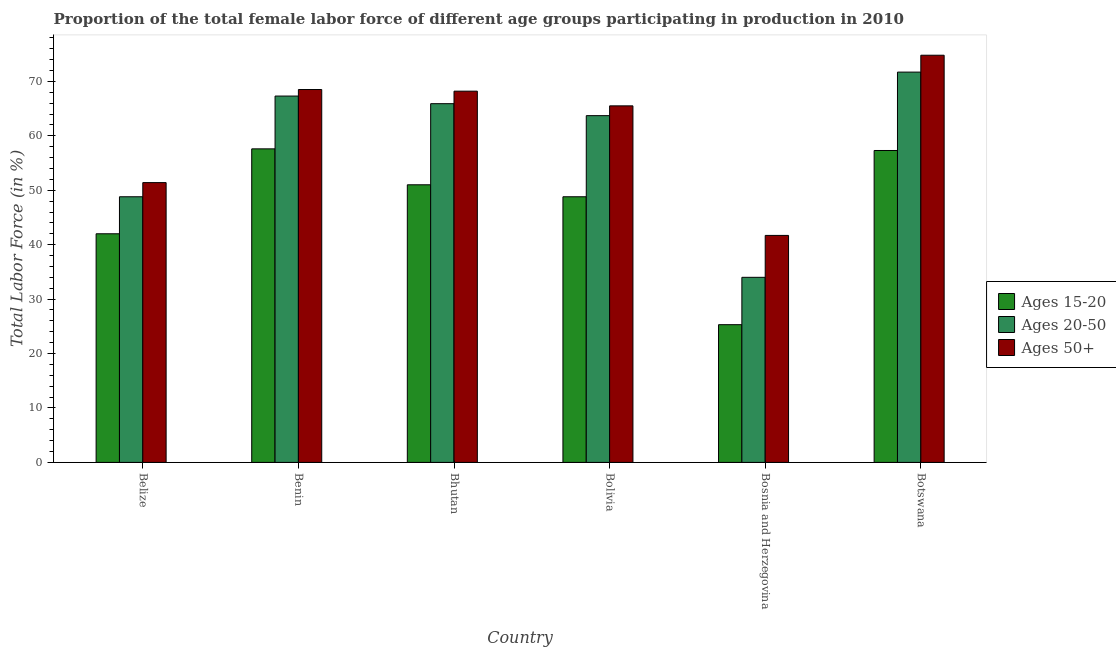How many groups of bars are there?
Offer a very short reply. 6. Are the number of bars on each tick of the X-axis equal?
Your response must be concise. Yes. How many bars are there on the 2nd tick from the left?
Ensure brevity in your answer.  3. What is the label of the 5th group of bars from the left?
Provide a short and direct response. Bosnia and Herzegovina. In how many cases, is the number of bars for a given country not equal to the number of legend labels?
Provide a short and direct response. 0. What is the percentage of female labor force above age 50 in Bhutan?
Your answer should be compact. 68.2. Across all countries, what is the maximum percentage of female labor force within the age group 20-50?
Make the answer very short. 71.7. Across all countries, what is the minimum percentage of female labor force within the age group 15-20?
Give a very brief answer. 25.3. In which country was the percentage of female labor force above age 50 maximum?
Offer a terse response. Botswana. In which country was the percentage of female labor force above age 50 minimum?
Offer a terse response. Bosnia and Herzegovina. What is the total percentage of female labor force above age 50 in the graph?
Make the answer very short. 370.1. What is the difference between the percentage of female labor force above age 50 in Belize and that in Bhutan?
Ensure brevity in your answer.  -16.8. What is the difference between the percentage of female labor force within the age group 20-50 in Belize and the percentage of female labor force within the age group 15-20 in Bosnia and Herzegovina?
Your answer should be very brief. 23.5. What is the average percentage of female labor force within the age group 20-50 per country?
Provide a short and direct response. 58.57. What is the difference between the percentage of female labor force above age 50 and percentage of female labor force within the age group 20-50 in Benin?
Offer a very short reply. 1.2. In how many countries, is the percentage of female labor force within the age group 15-20 greater than 74 %?
Your answer should be compact. 0. What is the ratio of the percentage of female labor force within the age group 15-20 in Bosnia and Herzegovina to that in Botswana?
Your response must be concise. 0.44. Is the percentage of female labor force within the age group 15-20 in Bolivia less than that in Bosnia and Herzegovina?
Provide a succinct answer. No. Is the difference between the percentage of female labor force within the age group 15-20 in Bhutan and Bosnia and Herzegovina greater than the difference between the percentage of female labor force above age 50 in Bhutan and Bosnia and Herzegovina?
Provide a succinct answer. No. What is the difference between the highest and the second highest percentage of female labor force above age 50?
Provide a short and direct response. 6.3. What is the difference between the highest and the lowest percentage of female labor force above age 50?
Offer a terse response. 33.1. In how many countries, is the percentage of female labor force within the age group 15-20 greater than the average percentage of female labor force within the age group 15-20 taken over all countries?
Make the answer very short. 4. What does the 3rd bar from the left in Botswana represents?
Offer a very short reply. Ages 50+. What does the 1st bar from the right in Belize represents?
Give a very brief answer. Ages 50+. Is it the case that in every country, the sum of the percentage of female labor force within the age group 15-20 and percentage of female labor force within the age group 20-50 is greater than the percentage of female labor force above age 50?
Make the answer very short. Yes. How many bars are there?
Your response must be concise. 18. What is the difference between two consecutive major ticks on the Y-axis?
Give a very brief answer. 10. Are the values on the major ticks of Y-axis written in scientific E-notation?
Ensure brevity in your answer.  No. Does the graph contain any zero values?
Provide a succinct answer. No. Does the graph contain grids?
Your answer should be very brief. No. Where does the legend appear in the graph?
Your answer should be compact. Center right. What is the title of the graph?
Your response must be concise. Proportion of the total female labor force of different age groups participating in production in 2010. What is the label or title of the X-axis?
Offer a terse response. Country. What is the label or title of the Y-axis?
Give a very brief answer. Total Labor Force (in %). What is the Total Labor Force (in %) of Ages 15-20 in Belize?
Ensure brevity in your answer.  42. What is the Total Labor Force (in %) of Ages 20-50 in Belize?
Your answer should be compact. 48.8. What is the Total Labor Force (in %) of Ages 50+ in Belize?
Your response must be concise. 51.4. What is the Total Labor Force (in %) in Ages 15-20 in Benin?
Your answer should be very brief. 57.6. What is the Total Labor Force (in %) of Ages 20-50 in Benin?
Keep it short and to the point. 67.3. What is the Total Labor Force (in %) in Ages 50+ in Benin?
Give a very brief answer. 68.5. What is the Total Labor Force (in %) of Ages 15-20 in Bhutan?
Your answer should be compact. 51. What is the Total Labor Force (in %) in Ages 20-50 in Bhutan?
Make the answer very short. 65.9. What is the Total Labor Force (in %) of Ages 50+ in Bhutan?
Your answer should be very brief. 68.2. What is the Total Labor Force (in %) of Ages 15-20 in Bolivia?
Ensure brevity in your answer.  48.8. What is the Total Labor Force (in %) in Ages 20-50 in Bolivia?
Your response must be concise. 63.7. What is the Total Labor Force (in %) of Ages 50+ in Bolivia?
Your answer should be compact. 65.5. What is the Total Labor Force (in %) in Ages 15-20 in Bosnia and Herzegovina?
Your response must be concise. 25.3. What is the Total Labor Force (in %) in Ages 20-50 in Bosnia and Herzegovina?
Keep it short and to the point. 34. What is the Total Labor Force (in %) of Ages 50+ in Bosnia and Herzegovina?
Provide a short and direct response. 41.7. What is the Total Labor Force (in %) of Ages 15-20 in Botswana?
Give a very brief answer. 57.3. What is the Total Labor Force (in %) in Ages 20-50 in Botswana?
Offer a terse response. 71.7. What is the Total Labor Force (in %) of Ages 50+ in Botswana?
Your response must be concise. 74.8. Across all countries, what is the maximum Total Labor Force (in %) of Ages 15-20?
Ensure brevity in your answer.  57.6. Across all countries, what is the maximum Total Labor Force (in %) of Ages 20-50?
Ensure brevity in your answer.  71.7. Across all countries, what is the maximum Total Labor Force (in %) in Ages 50+?
Provide a short and direct response. 74.8. Across all countries, what is the minimum Total Labor Force (in %) in Ages 15-20?
Keep it short and to the point. 25.3. Across all countries, what is the minimum Total Labor Force (in %) of Ages 20-50?
Your answer should be very brief. 34. Across all countries, what is the minimum Total Labor Force (in %) in Ages 50+?
Give a very brief answer. 41.7. What is the total Total Labor Force (in %) in Ages 15-20 in the graph?
Make the answer very short. 282. What is the total Total Labor Force (in %) of Ages 20-50 in the graph?
Provide a succinct answer. 351.4. What is the total Total Labor Force (in %) of Ages 50+ in the graph?
Your answer should be very brief. 370.1. What is the difference between the Total Labor Force (in %) of Ages 15-20 in Belize and that in Benin?
Your response must be concise. -15.6. What is the difference between the Total Labor Force (in %) of Ages 20-50 in Belize and that in Benin?
Your response must be concise. -18.5. What is the difference between the Total Labor Force (in %) of Ages 50+ in Belize and that in Benin?
Offer a very short reply. -17.1. What is the difference between the Total Labor Force (in %) of Ages 15-20 in Belize and that in Bhutan?
Offer a terse response. -9. What is the difference between the Total Labor Force (in %) of Ages 20-50 in Belize and that in Bhutan?
Your answer should be compact. -17.1. What is the difference between the Total Labor Force (in %) in Ages 50+ in Belize and that in Bhutan?
Offer a terse response. -16.8. What is the difference between the Total Labor Force (in %) of Ages 15-20 in Belize and that in Bolivia?
Provide a succinct answer. -6.8. What is the difference between the Total Labor Force (in %) of Ages 20-50 in Belize and that in Bolivia?
Your response must be concise. -14.9. What is the difference between the Total Labor Force (in %) in Ages 50+ in Belize and that in Bolivia?
Your answer should be very brief. -14.1. What is the difference between the Total Labor Force (in %) of Ages 15-20 in Belize and that in Bosnia and Herzegovina?
Keep it short and to the point. 16.7. What is the difference between the Total Labor Force (in %) in Ages 50+ in Belize and that in Bosnia and Herzegovina?
Offer a terse response. 9.7. What is the difference between the Total Labor Force (in %) in Ages 15-20 in Belize and that in Botswana?
Provide a succinct answer. -15.3. What is the difference between the Total Labor Force (in %) of Ages 20-50 in Belize and that in Botswana?
Provide a short and direct response. -22.9. What is the difference between the Total Labor Force (in %) of Ages 50+ in Belize and that in Botswana?
Your response must be concise. -23.4. What is the difference between the Total Labor Force (in %) of Ages 20-50 in Benin and that in Bhutan?
Provide a succinct answer. 1.4. What is the difference between the Total Labor Force (in %) of Ages 50+ in Benin and that in Bhutan?
Offer a terse response. 0.3. What is the difference between the Total Labor Force (in %) of Ages 20-50 in Benin and that in Bolivia?
Offer a very short reply. 3.6. What is the difference between the Total Labor Force (in %) of Ages 15-20 in Benin and that in Bosnia and Herzegovina?
Provide a succinct answer. 32.3. What is the difference between the Total Labor Force (in %) of Ages 20-50 in Benin and that in Bosnia and Herzegovina?
Make the answer very short. 33.3. What is the difference between the Total Labor Force (in %) of Ages 50+ in Benin and that in Bosnia and Herzegovina?
Ensure brevity in your answer.  26.8. What is the difference between the Total Labor Force (in %) in Ages 15-20 in Benin and that in Botswana?
Offer a terse response. 0.3. What is the difference between the Total Labor Force (in %) of Ages 50+ in Benin and that in Botswana?
Offer a terse response. -6.3. What is the difference between the Total Labor Force (in %) of Ages 20-50 in Bhutan and that in Bolivia?
Offer a very short reply. 2.2. What is the difference between the Total Labor Force (in %) in Ages 50+ in Bhutan and that in Bolivia?
Your answer should be compact. 2.7. What is the difference between the Total Labor Force (in %) in Ages 15-20 in Bhutan and that in Bosnia and Herzegovina?
Offer a terse response. 25.7. What is the difference between the Total Labor Force (in %) in Ages 20-50 in Bhutan and that in Bosnia and Herzegovina?
Offer a terse response. 31.9. What is the difference between the Total Labor Force (in %) in Ages 50+ in Bhutan and that in Bosnia and Herzegovina?
Your answer should be very brief. 26.5. What is the difference between the Total Labor Force (in %) of Ages 50+ in Bhutan and that in Botswana?
Offer a terse response. -6.6. What is the difference between the Total Labor Force (in %) in Ages 15-20 in Bolivia and that in Bosnia and Herzegovina?
Offer a very short reply. 23.5. What is the difference between the Total Labor Force (in %) in Ages 20-50 in Bolivia and that in Bosnia and Herzegovina?
Keep it short and to the point. 29.7. What is the difference between the Total Labor Force (in %) in Ages 50+ in Bolivia and that in Bosnia and Herzegovina?
Offer a very short reply. 23.8. What is the difference between the Total Labor Force (in %) of Ages 15-20 in Bolivia and that in Botswana?
Offer a very short reply. -8.5. What is the difference between the Total Labor Force (in %) of Ages 15-20 in Bosnia and Herzegovina and that in Botswana?
Your response must be concise. -32. What is the difference between the Total Labor Force (in %) of Ages 20-50 in Bosnia and Herzegovina and that in Botswana?
Your answer should be very brief. -37.7. What is the difference between the Total Labor Force (in %) in Ages 50+ in Bosnia and Herzegovina and that in Botswana?
Provide a succinct answer. -33.1. What is the difference between the Total Labor Force (in %) in Ages 15-20 in Belize and the Total Labor Force (in %) in Ages 20-50 in Benin?
Provide a succinct answer. -25.3. What is the difference between the Total Labor Force (in %) of Ages 15-20 in Belize and the Total Labor Force (in %) of Ages 50+ in Benin?
Make the answer very short. -26.5. What is the difference between the Total Labor Force (in %) of Ages 20-50 in Belize and the Total Labor Force (in %) of Ages 50+ in Benin?
Offer a terse response. -19.7. What is the difference between the Total Labor Force (in %) of Ages 15-20 in Belize and the Total Labor Force (in %) of Ages 20-50 in Bhutan?
Offer a terse response. -23.9. What is the difference between the Total Labor Force (in %) in Ages 15-20 in Belize and the Total Labor Force (in %) in Ages 50+ in Bhutan?
Keep it short and to the point. -26.2. What is the difference between the Total Labor Force (in %) in Ages 20-50 in Belize and the Total Labor Force (in %) in Ages 50+ in Bhutan?
Offer a terse response. -19.4. What is the difference between the Total Labor Force (in %) in Ages 15-20 in Belize and the Total Labor Force (in %) in Ages 20-50 in Bolivia?
Provide a succinct answer. -21.7. What is the difference between the Total Labor Force (in %) of Ages 15-20 in Belize and the Total Labor Force (in %) of Ages 50+ in Bolivia?
Make the answer very short. -23.5. What is the difference between the Total Labor Force (in %) of Ages 20-50 in Belize and the Total Labor Force (in %) of Ages 50+ in Bolivia?
Your response must be concise. -16.7. What is the difference between the Total Labor Force (in %) in Ages 15-20 in Belize and the Total Labor Force (in %) in Ages 20-50 in Bosnia and Herzegovina?
Make the answer very short. 8. What is the difference between the Total Labor Force (in %) of Ages 15-20 in Belize and the Total Labor Force (in %) of Ages 20-50 in Botswana?
Your answer should be very brief. -29.7. What is the difference between the Total Labor Force (in %) in Ages 15-20 in Belize and the Total Labor Force (in %) in Ages 50+ in Botswana?
Your answer should be compact. -32.8. What is the difference between the Total Labor Force (in %) in Ages 20-50 in Belize and the Total Labor Force (in %) in Ages 50+ in Botswana?
Provide a short and direct response. -26. What is the difference between the Total Labor Force (in %) of Ages 20-50 in Benin and the Total Labor Force (in %) of Ages 50+ in Bhutan?
Your answer should be very brief. -0.9. What is the difference between the Total Labor Force (in %) of Ages 15-20 in Benin and the Total Labor Force (in %) of Ages 20-50 in Bosnia and Herzegovina?
Keep it short and to the point. 23.6. What is the difference between the Total Labor Force (in %) in Ages 15-20 in Benin and the Total Labor Force (in %) in Ages 50+ in Bosnia and Herzegovina?
Ensure brevity in your answer.  15.9. What is the difference between the Total Labor Force (in %) of Ages 20-50 in Benin and the Total Labor Force (in %) of Ages 50+ in Bosnia and Herzegovina?
Your answer should be very brief. 25.6. What is the difference between the Total Labor Force (in %) in Ages 15-20 in Benin and the Total Labor Force (in %) in Ages 20-50 in Botswana?
Provide a succinct answer. -14.1. What is the difference between the Total Labor Force (in %) in Ages 15-20 in Benin and the Total Labor Force (in %) in Ages 50+ in Botswana?
Your response must be concise. -17.2. What is the difference between the Total Labor Force (in %) in Ages 15-20 in Bhutan and the Total Labor Force (in %) in Ages 20-50 in Bolivia?
Offer a terse response. -12.7. What is the difference between the Total Labor Force (in %) of Ages 15-20 in Bhutan and the Total Labor Force (in %) of Ages 20-50 in Bosnia and Herzegovina?
Your answer should be compact. 17. What is the difference between the Total Labor Force (in %) in Ages 20-50 in Bhutan and the Total Labor Force (in %) in Ages 50+ in Bosnia and Herzegovina?
Ensure brevity in your answer.  24.2. What is the difference between the Total Labor Force (in %) in Ages 15-20 in Bhutan and the Total Labor Force (in %) in Ages 20-50 in Botswana?
Your response must be concise. -20.7. What is the difference between the Total Labor Force (in %) in Ages 15-20 in Bhutan and the Total Labor Force (in %) in Ages 50+ in Botswana?
Ensure brevity in your answer.  -23.8. What is the difference between the Total Labor Force (in %) in Ages 15-20 in Bolivia and the Total Labor Force (in %) in Ages 20-50 in Bosnia and Herzegovina?
Your answer should be very brief. 14.8. What is the difference between the Total Labor Force (in %) in Ages 15-20 in Bolivia and the Total Labor Force (in %) in Ages 20-50 in Botswana?
Make the answer very short. -22.9. What is the difference between the Total Labor Force (in %) of Ages 20-50 in Bolivia and the Total Labor Force (in %) of Ages 50+ in Botswana?
Offer a very short reply. -11.1. What is the difference between the Total Labor Force (in %) in Ages 15-20 in Bosnia and Herzegovina and the Total Labor Force (in %) in Ages 20-50 in Botswana?
Your answer should be compact. -46.4. What is the difference between the Total Labor Force (in %) of Ages 15-20 in Bosnia and Herzegovina and the Total Labor Force (in %) of Ages 50+ in Botswana?
Offer a terse response. -49.5. What is the difference between the Total Labor Force (in %) of Ages 20-50 in Bosnia and Herzegovina and the Total Labor Force (in %) of Ages 50+ in Botswana?
Your answer should be compact. -40.8. What is the average Total Labor Force (in %) in Ages 15-20 per country?
Offer a terse response. 47. What is the average Total Labor Force (in %) in Ages 20-50 per country?
Make the answer very short. 58.57. What is the average Total Labor Force (in %) in Ages 50+ per country?
Your answer should be compact. 61.68. What is the difference between the Total Labor Force (in %) in Ages 20-50 and Total Labor Force (in %) in Ages 50+ in Benin?
Provide a short and direct response. -1.2. What is the difference between the Total Labor Force (in %) of Ages 15-20 and Total Labor Force (in %) of Ages 20-50 in Bhutan?
Your answer should be very brief. -14.9. What is the difference between the Total Labor Force (in %) in Ages 15-20 and Total Labor Force (in %) in Ages 50+ in Bhutan?
Offer a terse response. -17.2. What is the difference between the Total Labor Force (in %) in Ages 15-20 and Total Labor Force (in %) in Ages 20-50 in Bolivia?
Provide a short and direct response. -14.9. What is the difference between the Total Labor Force (in %) in Ages 15-20 and Total Labor Force (in %) in Ages 50+ in Bolivia?
Your answer should be very brief. -16.7. What is the difference between the Total Labor Force (in %) of Ages 20-50 and Total Labor Force (in %) of Ages 50+ in Bolivia?
Give a very brief answer. -1.8. What is the difference between the Total Labor Force (in %) of Ages 15-20 and Total Labor Force (in %) of Ages 50+ in Bosnia and Herzegovina?
Your answer should be compact. -16.4. What is the difference between the Total Labor Force (in %) in Ages 20-50 and Total Labor Force (in %) in Ages 50+ in Bosnia and Herzegovina?
Offer a very short reply. -7.7. What is the difference between the Total Labor Force (in %) of Ages 15-20 and Total Labor Force (in %) of Ages 20-50 in Botswana?
Your answer should be compact. -14.4. What is the difference between the Total Labor Force (in %) of Ages 15-20 and Total Labor Force (in %) of Ages 50+ in Botswana?
Offer a very short reply. -17.5. What is the difference between the Total Labor Force (in %) in Ages 20-50 and Total Labor Force (in %) in Ages 50+ in Botswana?
Your answer should be very brief. -3.1. What is the ratio of the Total Labor Force (in %) in Ages 15-20 in Belize to that in Benin?
Ensure brevity in your answer.  0.73. What is the ratio of the Total Labor Force (in %) in Ages 20-50 in Belize to that in Benin?
Your answer should be compact. 0.73. What is the ratio of the Total Labor Force (in %) in Ages 50+ in Belize to that in Benin?
Give a very brief answer. 0.75. What is the ratio of the Total Labor Force (in %) in Ages 15-20 in Belize to that in Bhutan?
Keep it short and to the point. 0.82. What is the ratio of the Total Labor Force (in %) in Ages 20-50 in Belize to that in Bhutan?
Offer a terse response. 0.74. What is the ratio of the Total Labor Force (in %) in Ages 50+ in Belize to that in Bhutan?
Make the answer very short. 0.75. What is the ratio of the Total Labor Force (in %) in Ages 15-20 in Belize to that in Bolivia?
Provide a succinct answer. 0.86. What is the ratio of the Total Labor Force (in %) of Ages 20-50 in Belize to that in Bolivia?
Your answer should be very brief. 0.77. What is the ratio of the Total Labor Force (in %) of Ages 50+ in Belize to that in Bolivia?
Your answer should be compact. 0.78. What is the ratio of the Total Labor Force (in %) in Ages 15-20 in Belize to that in Bosnia and Herzegovina?
Your response must be concise. 1.66. What is the ratio of the Total Labor Force (in %) in Ages 20-50 in Belize to that in Bosnia and Herzegovina?
Offer a very short reply. 1.44. What is the ratio of the Total Labor Force (in %) of Ages 50+ in Belize to that in Bosnia and Herzegovina?
Offer a terse response. 1.23. What is the ratio of the Total Labor Force (in %) in Ages 15-20 in Belize to that in Botswana?
Provide a short and direct response. 0.73. What is the ratio of the Total Labor Force (in %) of Ages 20-50 in Belize to that in Botswana?
Your answer should be compact. 0.68. What is the ratio of the Total Labor Force (in %) of Ages 50+ in Belize to that in Botswana?
Offer a very short reply. 0.69. What is the ratio of the Total Labor Force (in %) of Ages 15-20 in Benin to that in Bhutan?
Provide a succinct answer. 1.13. What is the ratio of the Total Labor Force (in %) of Ages 20-50 in Benin to that in Bhutan?
Provide a short and direct response. 1.02. What is the ratio of the Total Labor Force (in %) of Ages 50+ in Benin to that in Bhutan?
Ensure brevity in your answer.  1. What is the ratio of the Total Labor Force (in %) of Ages 15-20 in Benin to that in Bolivia?
Provide a short and direct response. 1.18. What is the ratio of the Total Labor Force (in %) of Ages 20-50 in Benin to that in Bolivia?
Make the answer very short. 1.06. What is the ratio of the Total Labor Force (in %) of Ages 50+ in Benin to that in Bolivia?
Give a very brief answer. 1.05. What is the ratio of the Total Labor Force (in %) of Ages 15-20 in Benin to that in Bosnia and Herzegovina?
Provide a succinct answer. 2.28. What is the ratio of the Total Labor Force (in %) of Ages 20-50 in Benin to that in Bosnia and Herzegovina?
Provide a short and direct response. 1.98. What is the ratio of the Total Labor Force (in %) of Ages 50+ in Benin to that in Bosnia and Herzegovina?
Provide a short and direct response. 1.64. What is the ratio of the Total Labor Force (in %) of Ages 20-50 in Benin to that in Botswana?
Give a very brief answer. 0.94. What is the ratio of the Total Labor Force (in %) in Ages 50+ in Benin to that in Botswana?
Provide a short and direct response. 0.92. What is the ratio of the Total Labor Force (in %) in Ages 15-20 in Bhutan to that in Bolivia?
Your response must be concise. 1.05. What is the ratio of the Total Labor Force (in %) of Ages 20-50 in Bhutan to that in Bolivia?
Offer a terse response. 1.03. What is the ratio of the Total Labor Force (in %) in Ages 50+ in Bhutan to that in Bolivia?
Your response must be concise. 1.04. What is the ratio of the Total Labor Force (in %) in Ages 15-20 in Bhutan to that in Bosnia and Herzegovina?
Offer a very short reply. 2.02. What is the ratio of the Total Labor Force (in %) of Ages 20-50 in Bhutan to that in Bosnia and Herzegovina?
Provide a succinct answer. 1.94. What is the ratio of the Total Labor Force (in %) of Ages 50+ in Bhutan to that in Bosnia and Herzegovina?
Give a very brief answer. 1.64. What is the ratio of the Total Labor Force (in %) of Ages 15-20 in Bhutan to that in Botswana?
Make the answer very short. 0.89. What is the ratio of the Total Labor Force (in %) in Ages 20-50 in Bhutan to that in Botswana?
Offer a terse response. 0.92. What is the ratio of the Total Labor Force (in %) of Ages 50+ in Bhutan to that in Botswana?
Give a very brief answer. 0.91. What is the ratio of the Total Labor Force (in %) of Ages 15-20 in Bolivia to that in Bosnia and Herzegovina?
Offer a very short reply. 1.93. What is the ratio of the Total Labor Force (in %) of Ages 20-50 in Bolivia to that in Bosnia and Herzegovina?
Provide a succinct answer. 1.87. What is the ratio of the Total Labor Force (in %) of Ages 50+ in Bolivia to that in Bosnia and Herzegovina?
Your answer should be very brief. 1.57. What is the ratio of the Total Labor Force (in %) in Ages 15-20 in Bolivia to that in Botswana?
Offer a very short reply. 0.85. What is the ratio of the Total Labor Force (in %) of Ages 20-50 in Bolivia to that in Botswana?
Offer a very short reply. 0.89. What is the ratio of the Total Labor Force (in %) in Ages 50+ in Bolivia to that in Botswana?
Offer a very short reply. 0.88. What is the ratio of the Total Labor Force (in %) in Ages 15-20 in Bosnia and Herzegovina to that in Botswana?
Offer a very short reply. 0.44. What is the ratio of the Total Labor Force (in %) in Ages 20-50 in Bosnia and Herzegovina to that in Botswana?
Ensure brevity in your answer.  0.47. What is the ratio of the Total Labor Force (in %) of Ages 50+ in Bosnia and Herzegovina to that in Botswana?
Offer a terse response. 0.56. What is the difference between the highest and the second highest Total Labor Force (in %) in Ages 15-20?
Ensure brevity in your answer.  0.3. What is the difference between the highest and the second highest Total Labor Force (in %) of Ages 20-50?
Your response must be concise. 4.4. What is the difference between the highest and the lowest Total Labor Force (in %) of Ages 15-20?
Provide a short and direct response. 32.3. What is the difference between the highest and the lowest Total Labor Force (in %) of Ages 20-50?
Provide a succinct answer. 37.7. What is the difference between the highest and the lowest Total Labor Force (in %) in Ages 50+?
Your response must be concise. 33.1. 